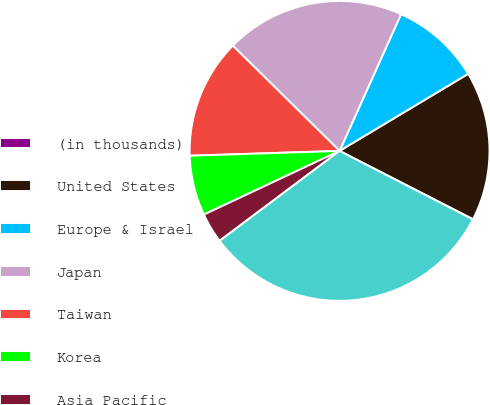<chart> <loc_0><loc_0><loc_500><loc_500><pie_chart><fcel>(in thousands)<fcel>United States<fcel>Europe & Israel<fcel>Japan<fcel>Taiwan<fcel>Korea<fcel>Asia Pacific<fcel>Total<nl><fcel>0.03%<fcel>16.12%<fcel>9.68%<fcel>19.34%<fcel>12.9%<fcel>6.47%<fcel>3.25%<fcel>32.21%<nl></chart> 